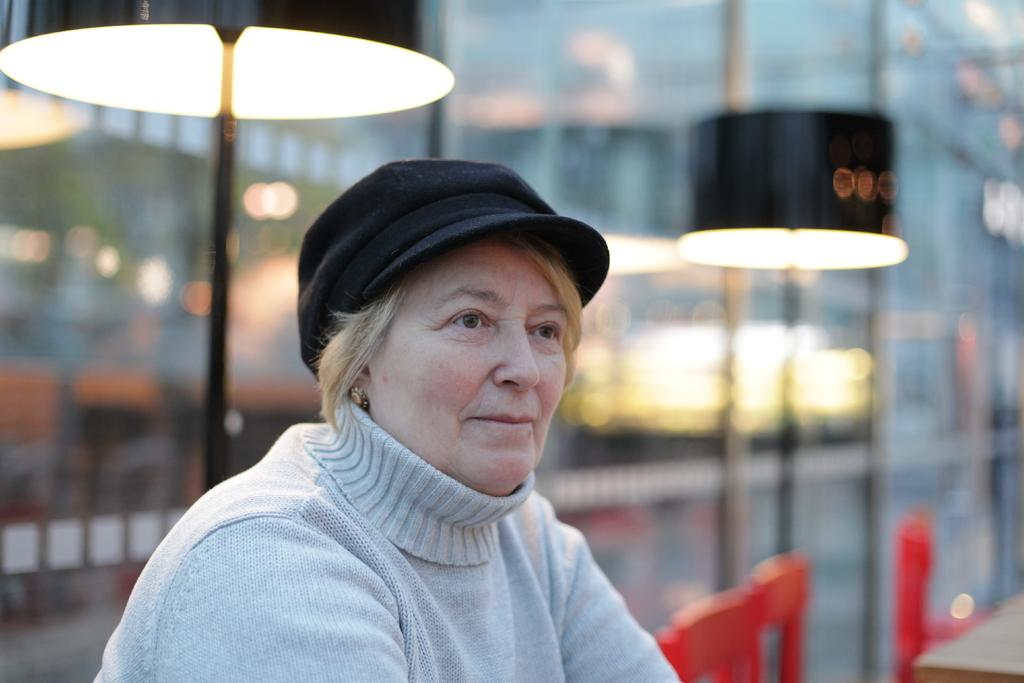What is present in the image? There is a person in the image. Can you describe the person's attire? The person is wearing clothes and a cap. What can be seen at the top of the image? There are lamps at the top of the image. What is located in the bottom right of the image? There are chairs in the bottom right of the image. What time is it in the image? The image does not provide any information about the time. How does the person increase the brightness of the lamps in the image? The image does not show any action or interaction with the lamps, so it is not possible to determine how the person might increase their brightness. 